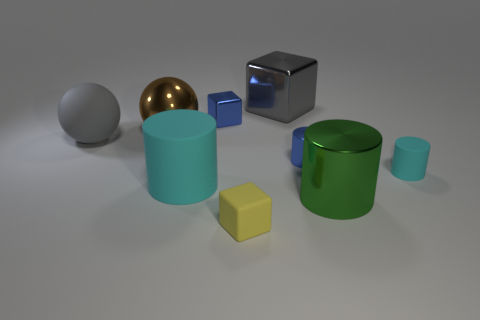Add 1 tiny things. How many objects exist? 10 Subtract all cubes. How many objects are left? 6 Subtract all blue metallic things. Subtract all small rubber cylinders. How many objects are left? 6 Add 1 big cyan matte cylinders. How many big cyan matte cylinders are left? 2 Add 3 purple cylinders. How many purple cylinders exist? 3 Subtract 0 yellow balls. How many objects are left? 9 